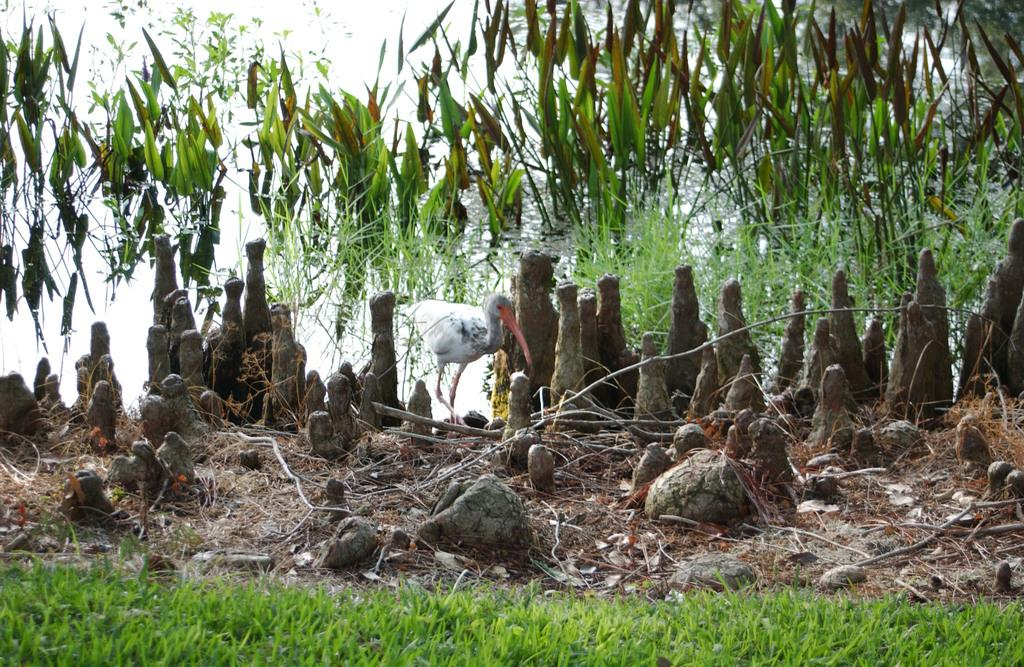What type of animal is in the image? There is a bird in the image. What color is the bird? The bird is white in color. What can be seen in the background of the image? There are plants and the sky visible in the background of the image. What color are the plants? The plants are green in color. What color is the sky in the image? The sky is white in color. What type of religious ceremony is taking place in the image? There is no indication of a religious ceremony in the image; it features a white bird, green plants, and a white sky. Can you tell me how many kettles are visible in the image? There are no kettles present in the image. 